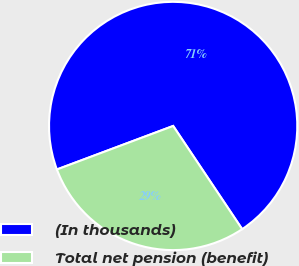Convert chart. <chart><loc_0><loc_0><loc_500><loc_500><pie_chart><fcel>(In thousands)<fcel>Total net pension (benefit)<nl><fcel>71.32%<fcel>28.68%<nl></chart> 